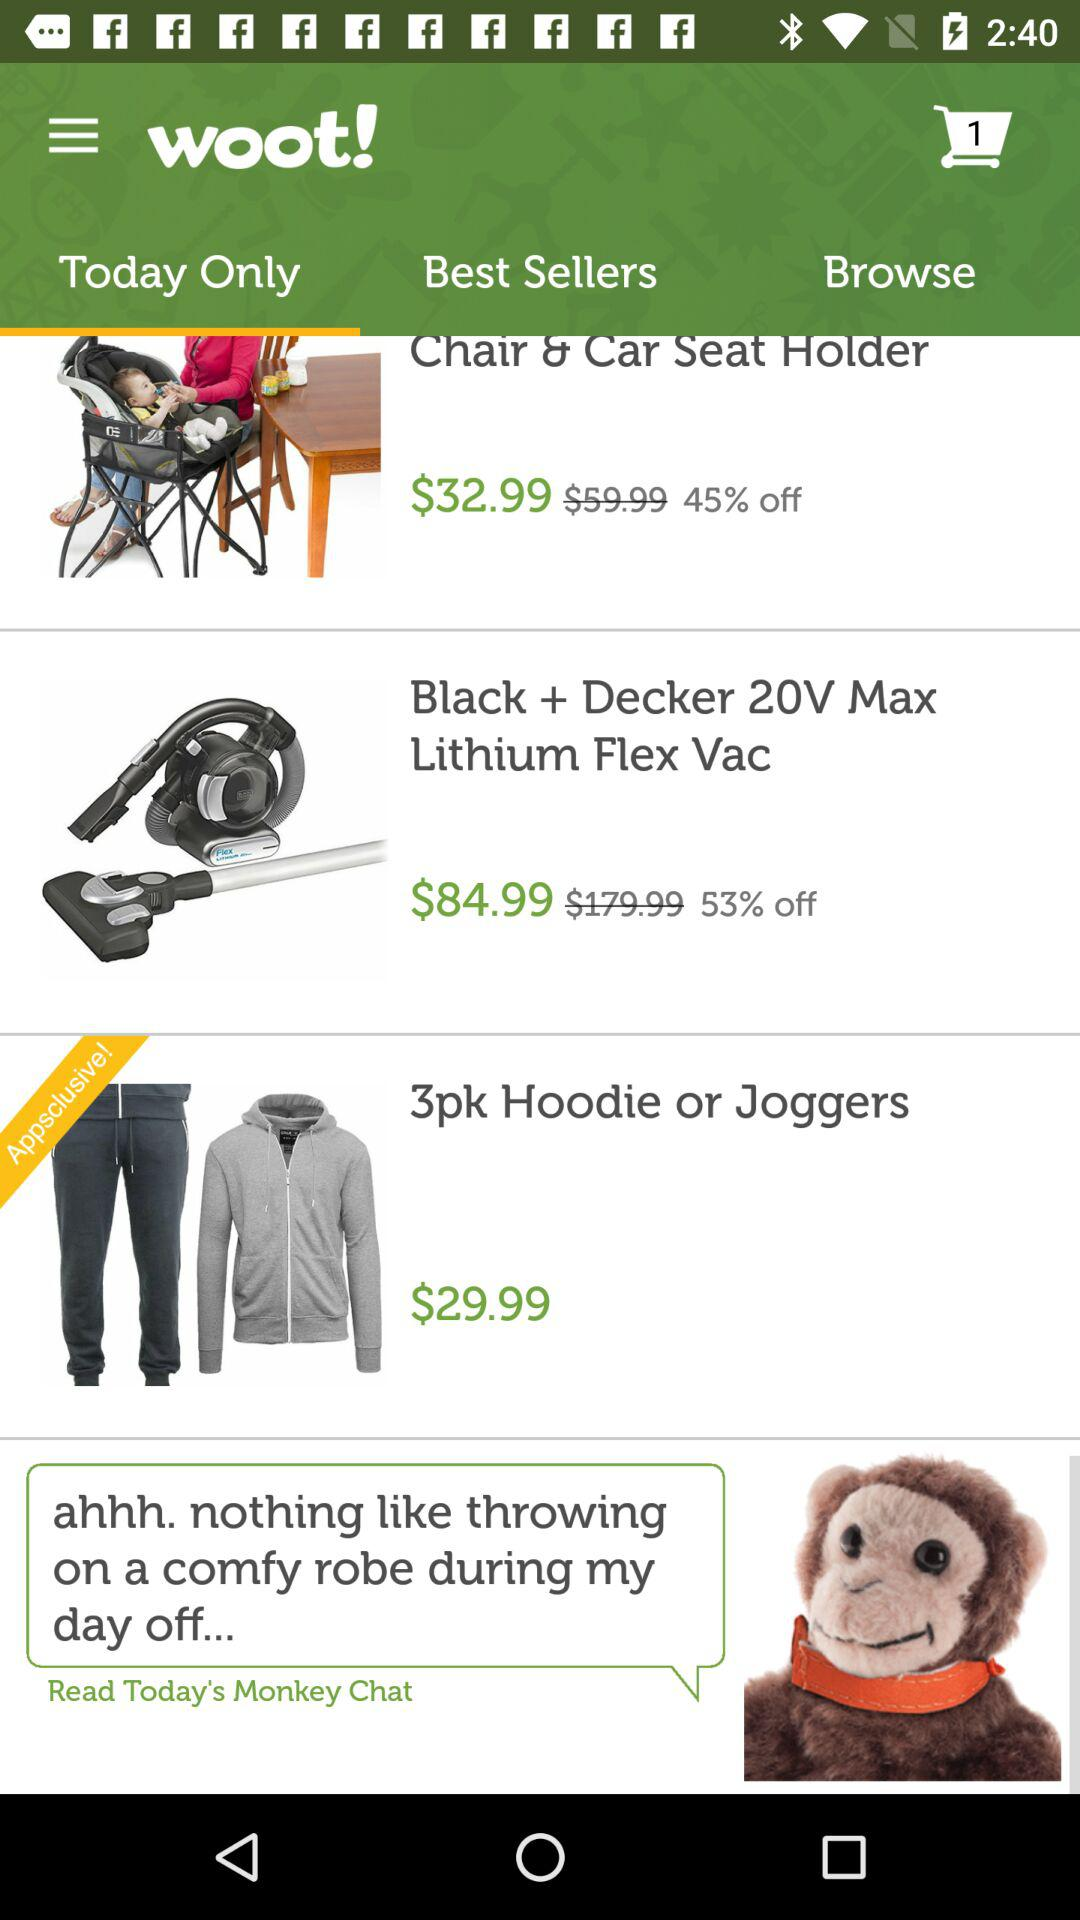How much discount is on the "Black + Decker 20V Max Lithium Flex Vac"? The discount is 53%. 